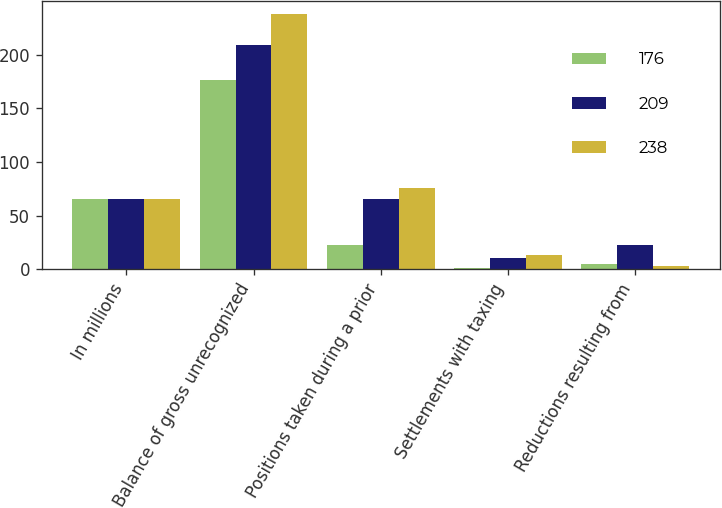Convert chart to OTSL. <chart><loc_0><loc_0><loc_500><loc_500><stacked_bar_chart><ecel><fcel>In millions<fcel>Balance of gross unrecognized<fcel>Positions taken during a prior<fcel>Settlements with taxing<fcel>Reductions resulting from<nl><fcel>176<fcel>65<fcel>176<fcel>23<fcel>1<fcel>5<nl><fcel>209<fcel>65<fcel>209<fcel>65<fcel>10<fcel>23<nl><fcel>238<fcel>65<fcel>238<fcel>76<fcel>13<fcel>3<nl></chart> 